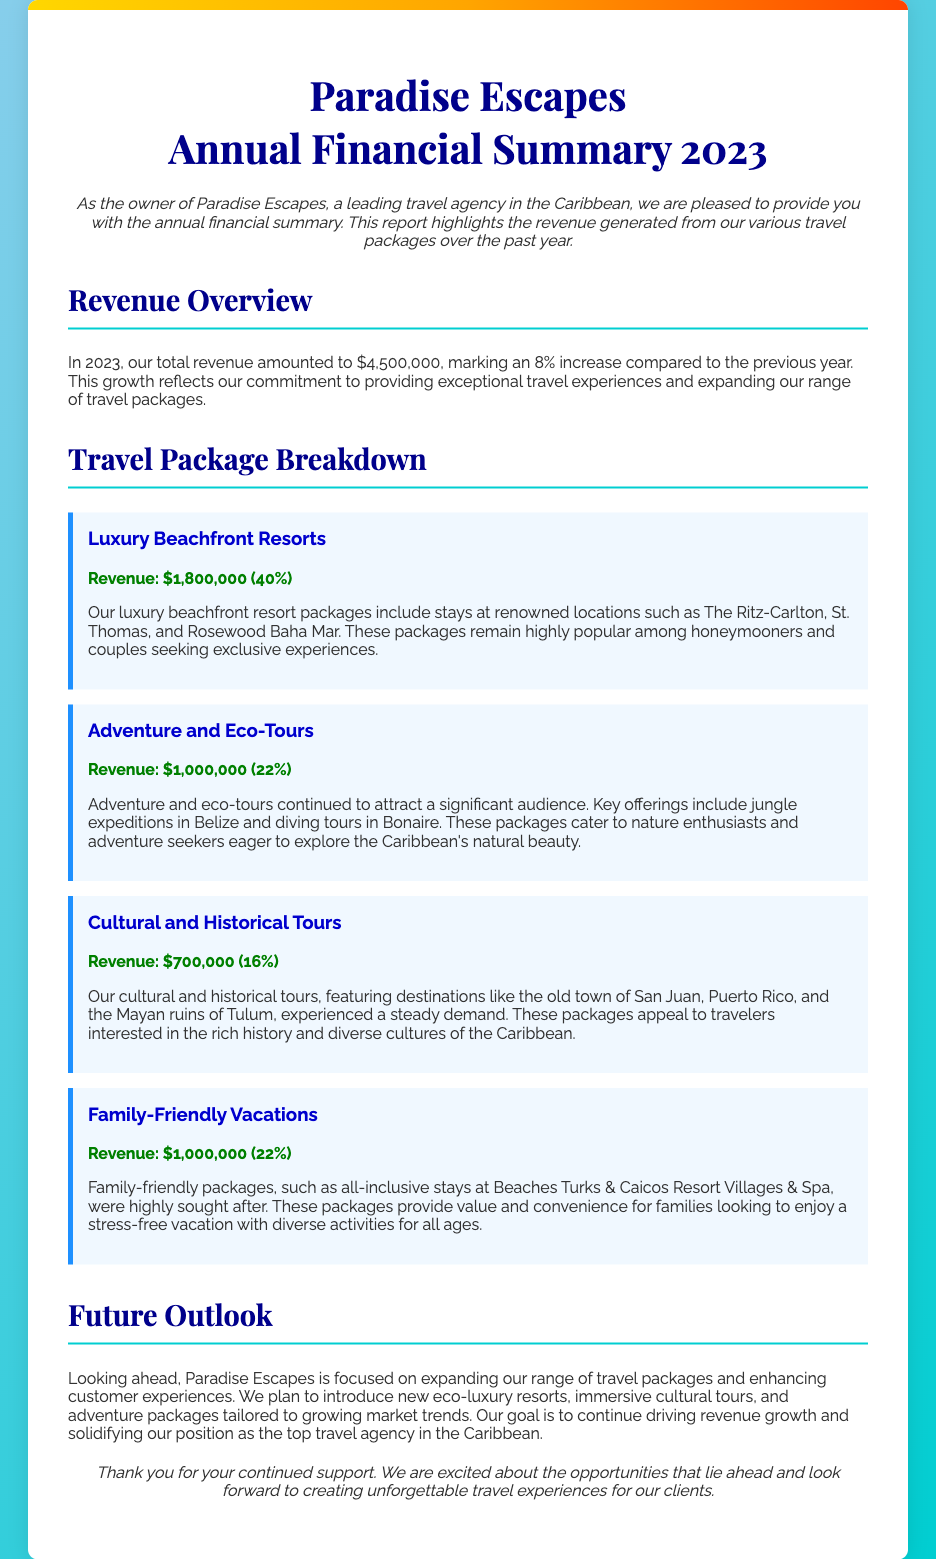What is the total revenue for 2023? The total revenue for 2023 is stated at the beginning of the revenue overview section.
Answer: $4,500,000 What was the revenue increase percentage compared to the previous year? The document mentions an 8% increase compared to the previous year.
Answer: 8% How much revenue did Luxury Beachfront Resorts generate? The revenue generated from Luxury Beachfront Resorts is specified in the travel package breakdown.
Answer: $1,800,000 What percentage of total revenue is from Adventure and Eco-Tours? The document provides the revenue breakdown, and Adventure and Eco-Tours' percentage is included.
Answer: 22% Which travel package generated the highest revenue? The revenue section clearly indicates which package generated the most revenue.
Answer: Luxury Beachfront Resorts What type of tours cater to nature enthusiasts? The document discusses the characteristics of different tours, specifying which ones are aimed at this audience.
Answer: Adventure and Eco-Tours How much revenue was generated from Cultural and Historical Tours? The revenue for Cultural and Historical Tours is listed in the travel package breakdown section.
Answer: $700,000 What is emphasized in the future outlook section? The future outlook discusses the agency's plans, which are outlined in a concise manner in the document.
Answer: Expanding travel packages What was the main clientele for Family-Friendly Vacations? The document hints at who the typical clients might be for these packages based on descriptions provided.
Answer: Families 